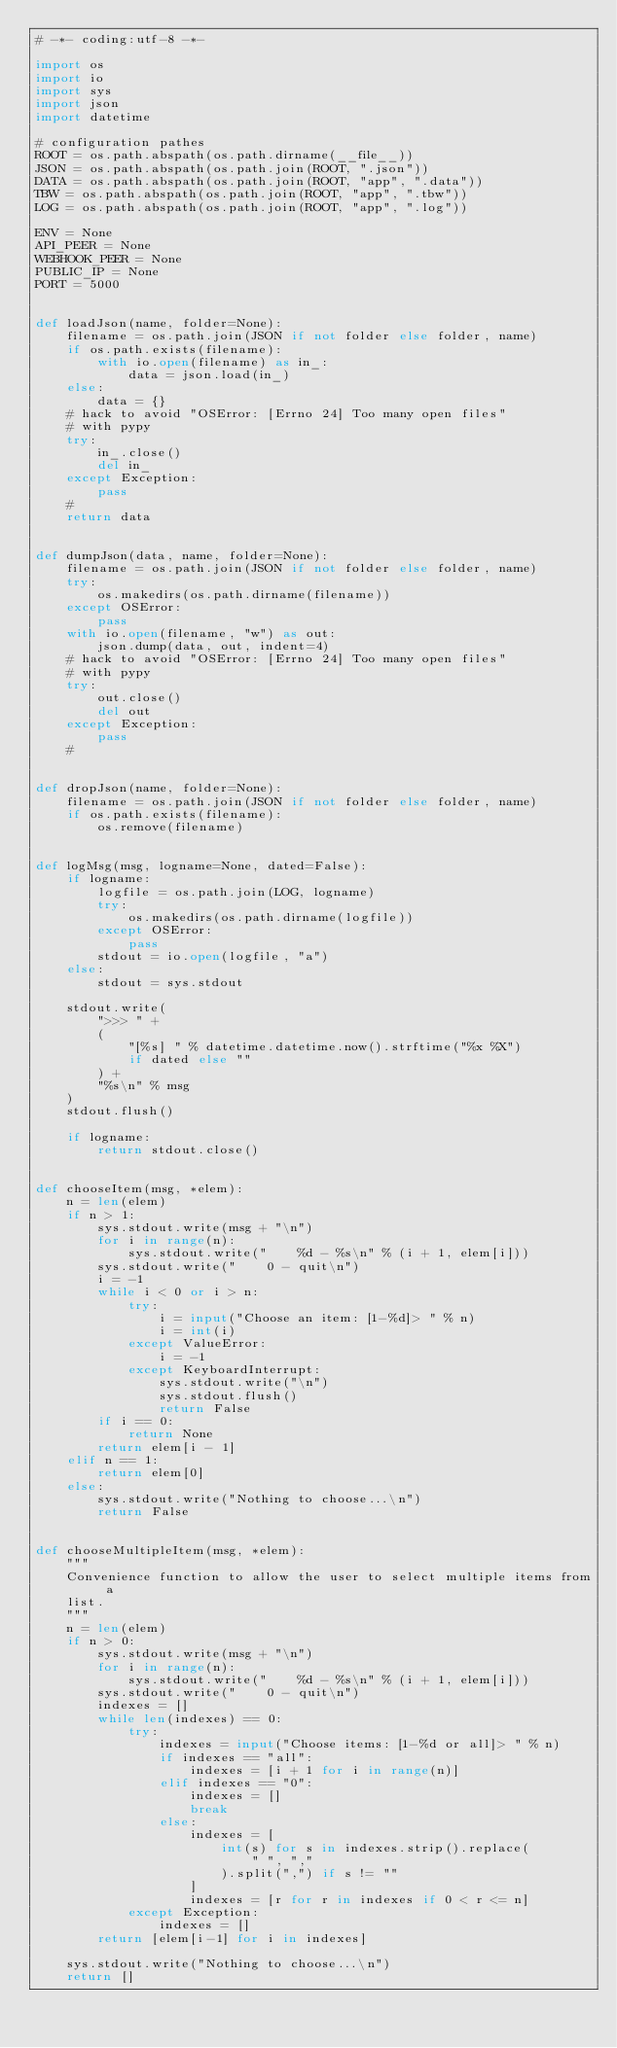<code> <loc_0><loc_0><loc_500><loc_500><_Python_># -*- coding:utf-8 -*-

import os
import io
import sys
import json
import datetime

# configuration pathes
ROOT = os.path.abspath(os.path.dirname(__file__))
JSON = os.path.abspath(os.path.join(ROOT, ".json"))
DATA = os.path.abspath(os.path.join(ROOT, "app", ".data"))
TBW = os.path.abspath(os.path.join(ROOT, "app", ".tbw"))
LOG = os.path.abspath(os.path.join(ROOT, "app", ".log"))

ENV = None
API_PEER = None
WEBHOOK_PEER = None
PUBLIC_IP = None
PORT = 5000


def loadJson(name, folder=None):
    filename = os.path.join(JSON if not folder else folder, name)
    if os.path.exists(filename):
        with io.open(filename) as in_:
            data = json.load(in_)
    else:
        data = {}
    # hack to avoid "OSError: [Errno 24] Too many open files"
    # with pypy
    try:
        in_.close()
        del in_
    except Exception:
        pass
    #
    return data


def dumpJson(data, name, folder=None):
    filename = os.path.join(JSON if not folder else folder, name)
    try:
        os.makedirs(os.path.dirname(filename))
    except OSError:
        pass
    with io.open(filename, "w") as out:
        json.dump(data, out, indent=4)
    # hack to avoid "OSError: [Errno 24] Too many open files"
    # with pypy
    try:
        out.close()
        del out
    except Exception:
        pass
    #


def dropJson(name, folder=None):
    filename = os.path.join(JSON if not folder else folder, name)
    if os.path.exists(filename):
        os.remove(filename)


def logMsg(msg, logname=None, dated=False):
    if logname:
        logfile = os.path.join(LOG, logname)
        try:
            os.makedirs(os.path.dirname(logfile))
        except OSError:
            pass
        stdout = io.open(logfile, "a")
    else:
        stdout = sys.stdout

    stdout.write(
        ">>> " +
        (
            "[%s] " % datetime.datetime.now().strftime("%x %X")
            if dated else ""
        ) +
        "%s\n" % msg
    )
    stdout.flush()

    if logname:
        return stdout.close()


def chooseItem(msg, *elem):
    n = len(elem)
    if n > 1:
        sys.stdout.write(msg + "\n")
        for i in range(n):
            sys.stdout.write("    %d - %s\n" % (i + 1, elem[i]))
        sys.stdout.write("    0 - quit\n")
        i = -1
        while i < 0 or i > n:
            try:
                i = input("Choose an item: [1-%d]> " % n)
                i = int(i)
            except ValueError:
                i = -1
            except KeyboardInterrupt:
                sys.stdout.write("\n")
                sys.stdout.flush()
                return False
        if i == 0:
            return None
        return elem[i - 1]
    elif n == 1:
        return elem[0]
    else:
        sys.stdout.write("Nothing to choose...\n")
        return False


def chooseMultipleItem(msg, *elem):
    """
    Convenience function to allow the user to select multiple items from a
    list.
    """
    n = len(elem)
    if n > 0:
        sys.stdout.write(msg + "\n")
        for i in range(n):
            sys.stdout.write("    %d - %s\n" % (i + 1, elem[i]))
        sys.stdout.write("    0 - quit\n")
        indexes = []
        while len(indexes) == 0:
            try:
                indexes = input("Choose items: [1-%d or all]> " % n)
                if indexes == "all":
                    indexes = [i + 1 for i in range(n)]
                elif indexes == "0":
                    indexes = []
                    break
                else:
                    indexes = [
                        int(s) for s in indexes.strip().replace(
                            " ", ","
                        ).split(",") if s != ""
                    ]
                    indexes = [r for r in indexes if 0 < r <= n]
            except Exception:
                indexes = []
        return [elem[i-1] for i in indexes]

    sys.stdout.write("Nothing to choose...\n")
    return []
</code> 